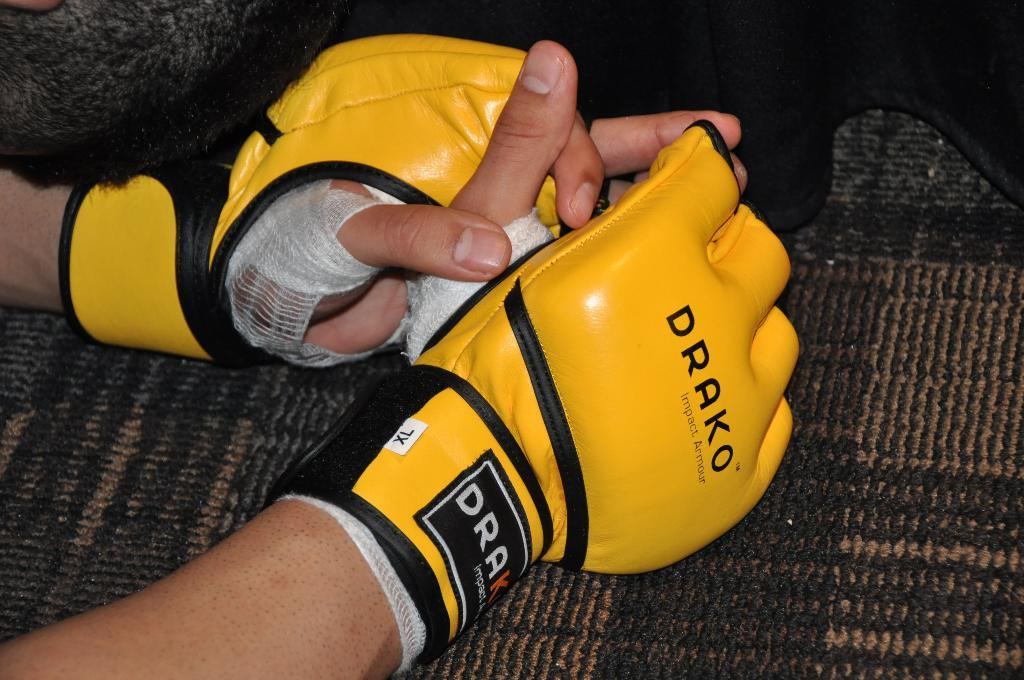How many hands are visible in the image? There are two hands in the image. To whom do the hands belong? The hands belong to a person. What is the person wearing on their hands? The person is wearing gloves. What type of porter can be seen carrying a bag in the image? There is no porter carrying a bag present in the image; it only features two hands wearing gloves. How does the fang interact with the hands in the image? There is no fang present in the image, so it cannot interact with the hands. 